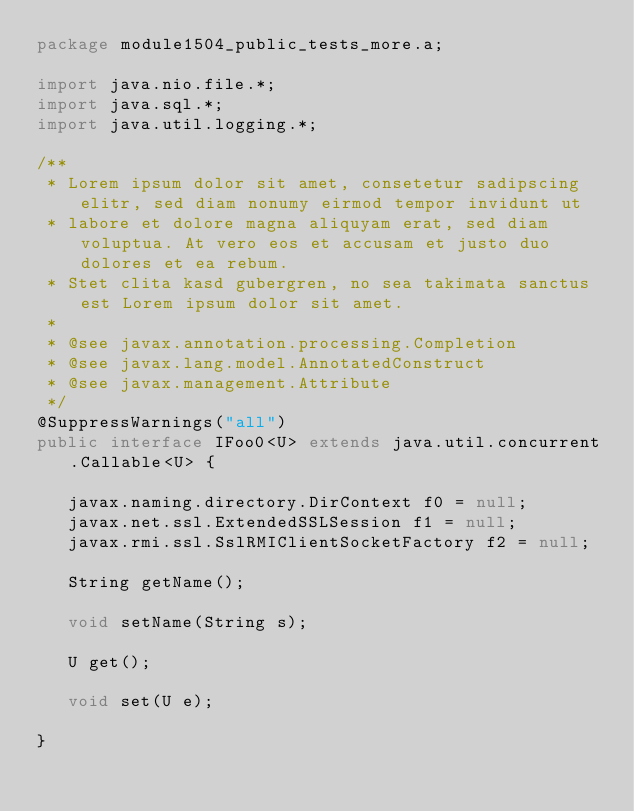<code> <loc_0><loc_0><loc_500><loc_500><_Java_>package module1504_public_tests_more.a;

import java.nio.file.*;
import java.sql.*;
import java.util.logging.*;

/**
 * Lorem ipsum dolor sit amet, consetetur sadipscing elitr, sed diam nonumy eirmod tempor invidunt ut 
 * labore et dolore magna aliquyam erat, sed diam voluptua. At vero eos et accusam et justo duo dolores et ea rebum. 
 * Stet clita kasd gubergren, no sea takimata sanctus est Lorem ipsum dolor sit amet. 
 *
 * @see javax.annotation.processing.Completion
 * @see javax.lang.model.AnnotatedConstruct
 * @see javax.management.Attribute
 */
@SuppressWarnings("all")
public interface IFoo0<U> extends java.util.concurrent.Callable<U> {

	 javax.naming.directory.DirContext f0 = null;
	 javax.net.ssl.ExtendedSSLSession f1 = null;
	 javax.rmi.ssl.SslRMIClientSocketFactory f2 = null;

	 String getName();

	 void setName(String s);

	 U get();

	 void set(U e);

}
</code> 